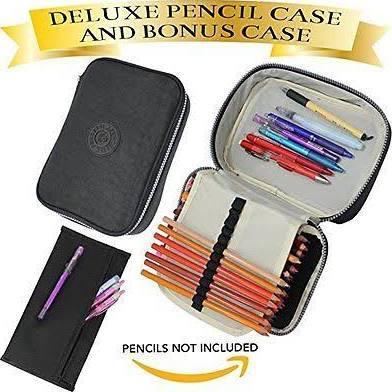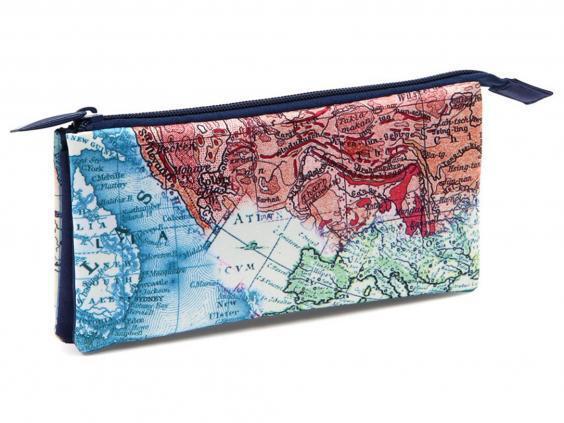The first image is the image on the left, the second image is the image on the right. For the images displayed, is the sentence "The left image contain a single pencil case that is predominantly pink." factually correct? Answer yes or no. No. The first image is the image on the left, the second image is the image on the right. Evaluate the accuracy of this statement regarding the images: "At least one pencil case does not use a zipper to close.". Is it true? Answer yes or no. No. The first image is the image on the left, the second image is the image on the right. Examine the images to the left and right. Is the description "Multiple writing implements are shown with pencil cases in each image." accurate? Answer yes or no. No. 